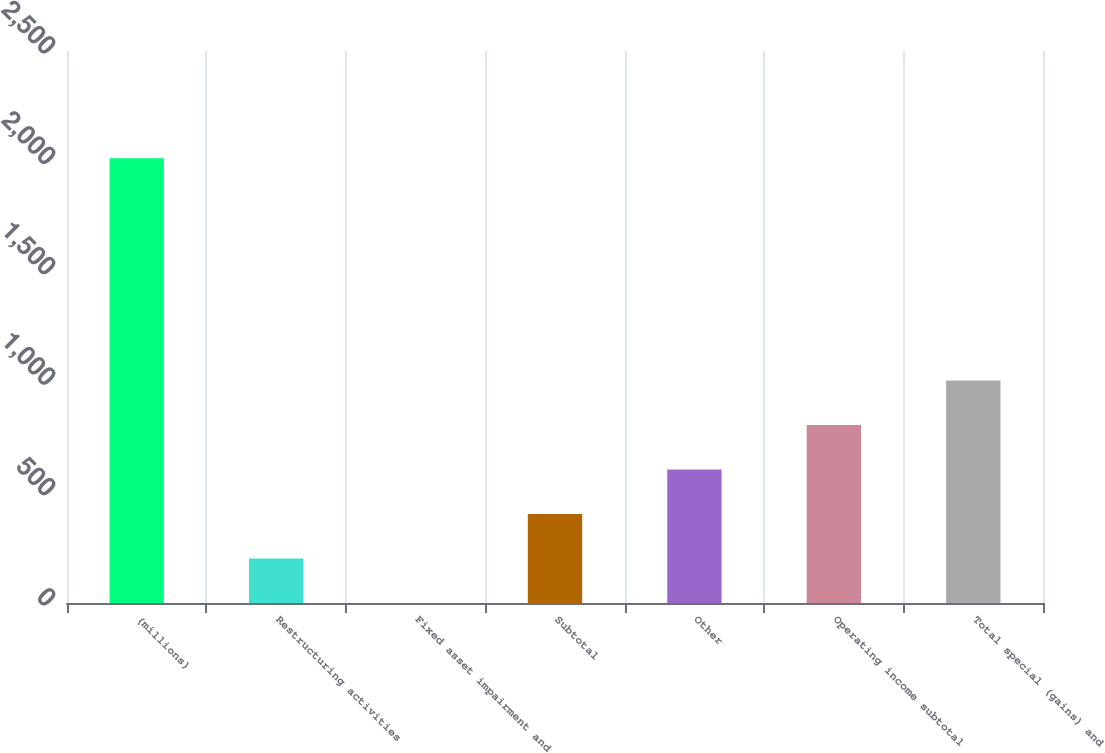<chart> <loc_0><loc_0><loc_500><loc_500><bar_chart><fcel>(millions)<fcel>Restructuring activities<fcel>Fixed asset impairment and<fcel>Subtotal<fcel>Other<fcel>Operating income subtotal<fcel>Total special (gains) and<nl><fcel>2014<fcel>201.76<fcel>0.4<fcel>403.12<fcel>604.48<fcel>805.84<fcel>1007.2<nl></chart> 